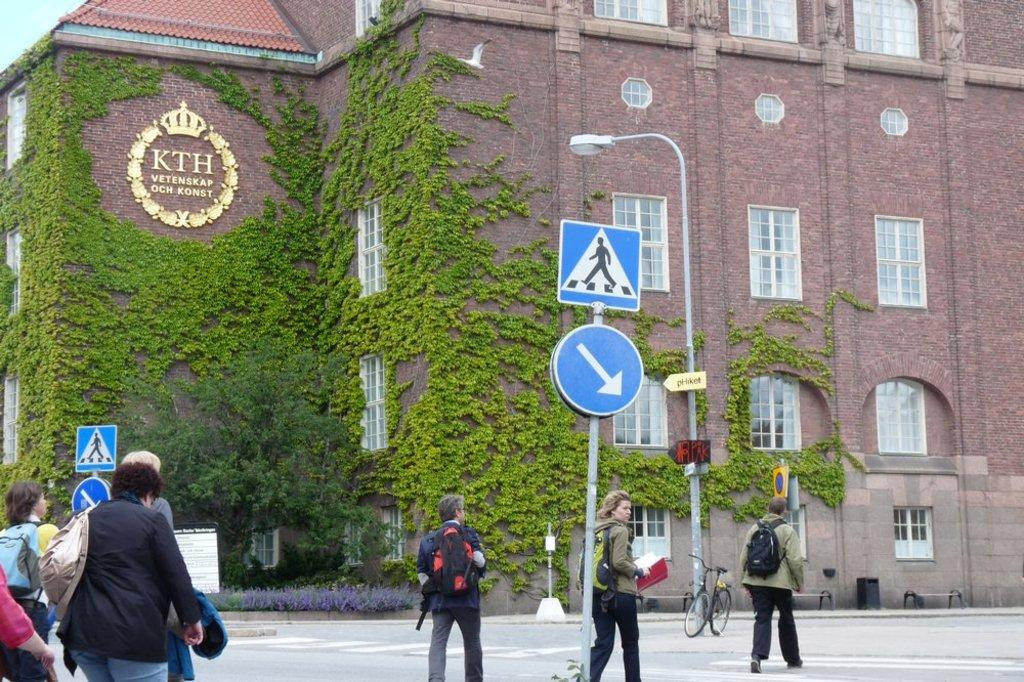What are the two persons in the image doing? The two persons in the image are walking on the road. Where is the road located in the image? The road is on the left side of the image. What can be seen in the middle of the image? There is a sign board in the middle of the image. What type of structure is visible in the image? There is a building in the image. What can be seen on the building? Green plants are present on the building. What type of brass instrument is being played by the person on the right side of the image? There is no brass instrument or person on the right side of the image; it only shows two persons walking on the road. 